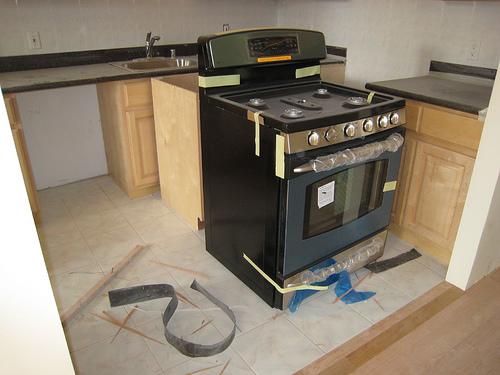Is this a new stove?
Give a very brief answer. Yes. Has the stove been installed yet?
Write a very short answer. No. Is there a sink in the photo?
Answer briefly. Yes. Who is at work here?
Give a very brief answer. No one. 